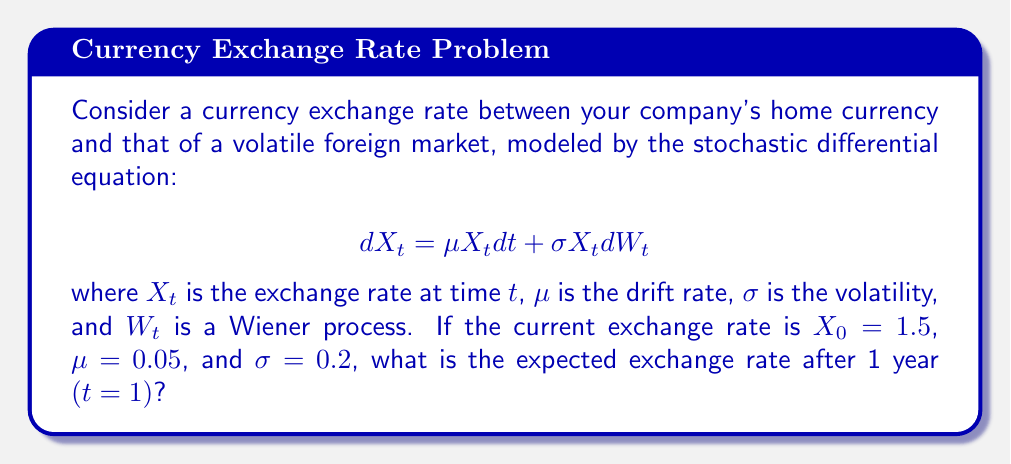Show me your answer to this math problem. To solve this problem, we'll follow these steps:

1) The stochastic differential equation given is for a geometric Brownian motion, which is commonly used to model currency exchange rates and stock prices.

2) For a geometric Brownian motion, the expected value of $X_t$ at time $t$ is given by the formula:

   $$E[X_t] = X_0 e^{\mu t}$$

3) We are given:
   - $X_0 = 1.5$ (initial exchange rate)
   - $\mu = 0.05$ (drift rate)
   - $t = 1$ (time in years)

4) Let's substitute these values into the formula:

   $$E[X_1] = 1.5 e^{0.05 * 1}$$

5) Now, let's calculate:

   $$E[X_1] = 1.5 e^{0.05} \approx 1.5 * 1.0513 \approx 1.5769$$

6) Therefore, the expected exchange rate after 1 year is approximately 1.5769.

Note: The volatility $\sigma$ does not appear in the expectation formula. It affects the variability of the exchange rate but not its expected value.
Answer: 1.5769 